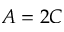<formula> <loc_0><loc_0><loc_500><loc_500>A = 2 C</formula> 